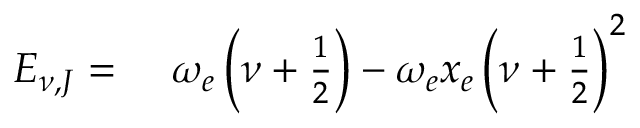<formula> <loc_0><loc_0><loc_500><loc_500>\begin{array} { r l } { E _ { \nu , J } = \ } & \omega _ { e } \left ( \nu + \frac { 1 } { 2 } \right ) - \omega _ { e } x _ { e } \left ( \nu + \frac { 1 } { 2 } \right ) ^ { 2 } } \end{array}</formula> 